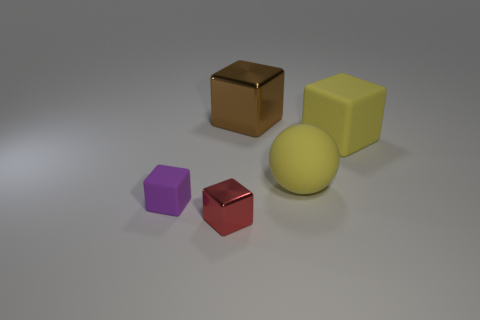What number of blocks are either brown rubber things or tiny red shiny objects? In the image, there is one brown block that appears to have a rubber-like texture, and one small red object with a shiny surface. Therefore, the total number of objects that meet the criteria is two. 